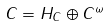<formula> <loc_0><loc_0><loc_500><loc_500>C = H _ { C } \oplus C ^ { \omega }</formula> 